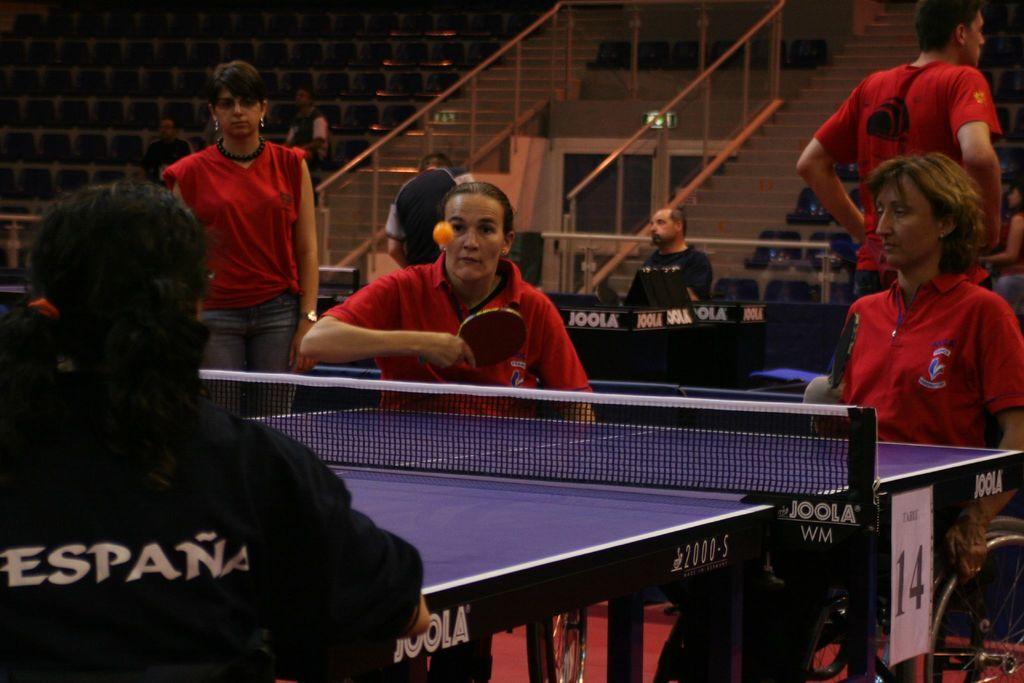Describe this image in one or two sentences. There are handicapped people playing table tennis and there are some other people in the background. 